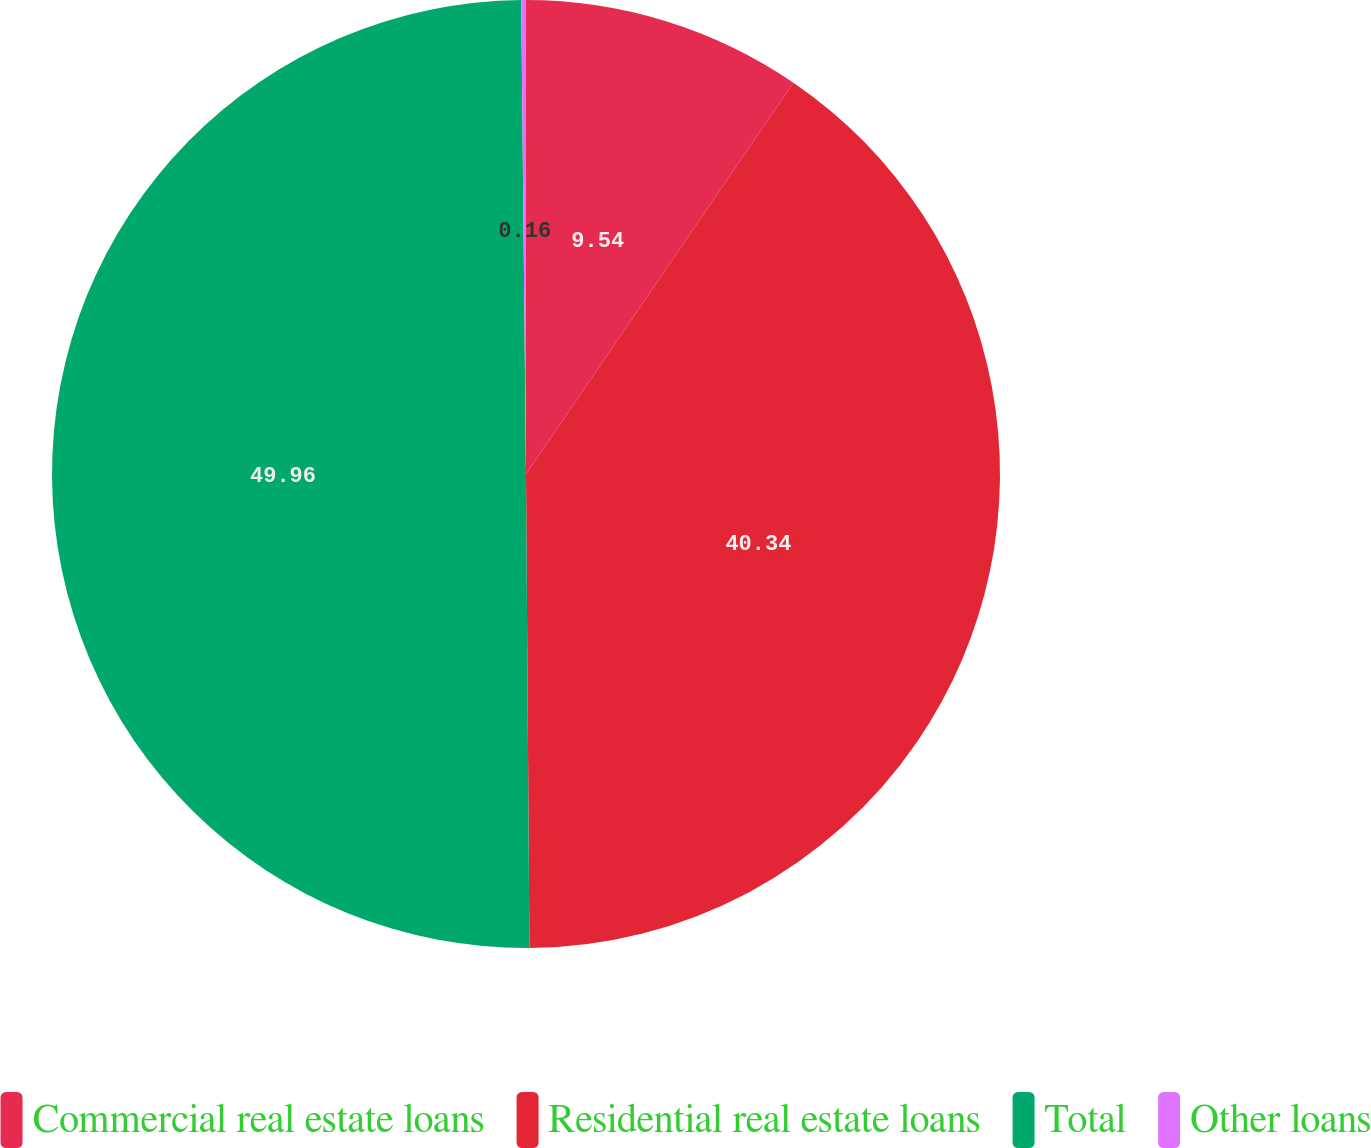<chart> <loc_0><loc_0><loc_500><loc_500><pie_chart><fcel>Commercial real estate loans<fcel>Residential real estate loans<fcel>Total<fcel>Other loans<nl><fcel>9.54%<fcel>40.34%<fcel>49.95%<fcel>0.16%<nl></chart> 